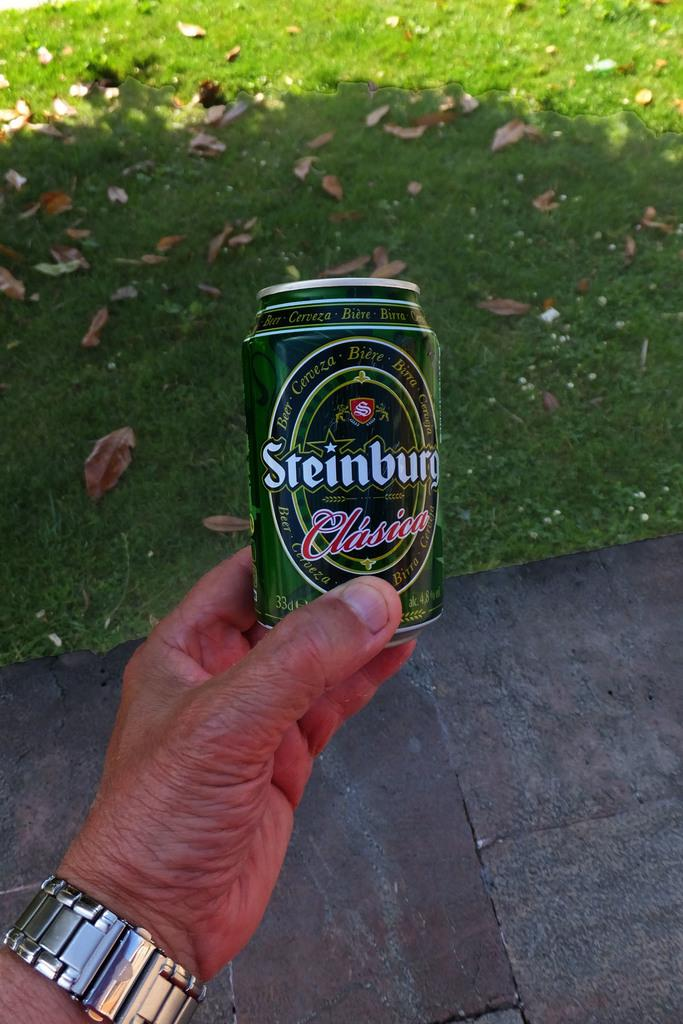<image>
Present a compact description of the photo's key features. A hand holding a can of Steinburg beer 